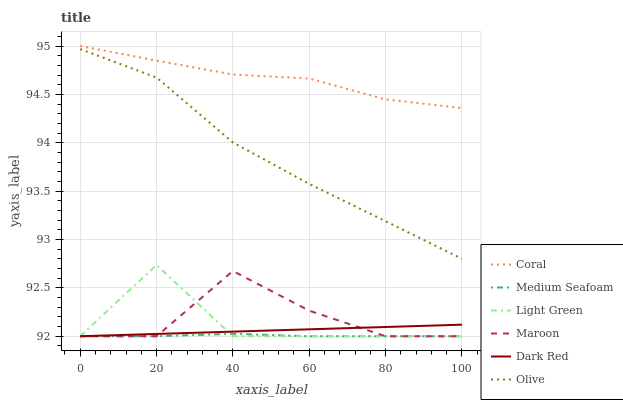Does Maroon have the minimum area under the curve?
Answer yes or no. No. Does Maroon have the maximum area under the curve?
Answer yes or no. No. Is Coral the smoothest?
Answer yes or no. No. Is Coral the roughest?
Answer yes or no. No. Does Coral have the lowest value?
Answer yes or no. No. Does Maroon have the highest value?
Answer yes or no. No. Is Maroon less than Olive?
Answer yes or no. Yes. Is Olive greater than Medium Seafoam?
Answer yes or no. Yes. Does Maroon intersect Olive?
Answer yes or no. No. 